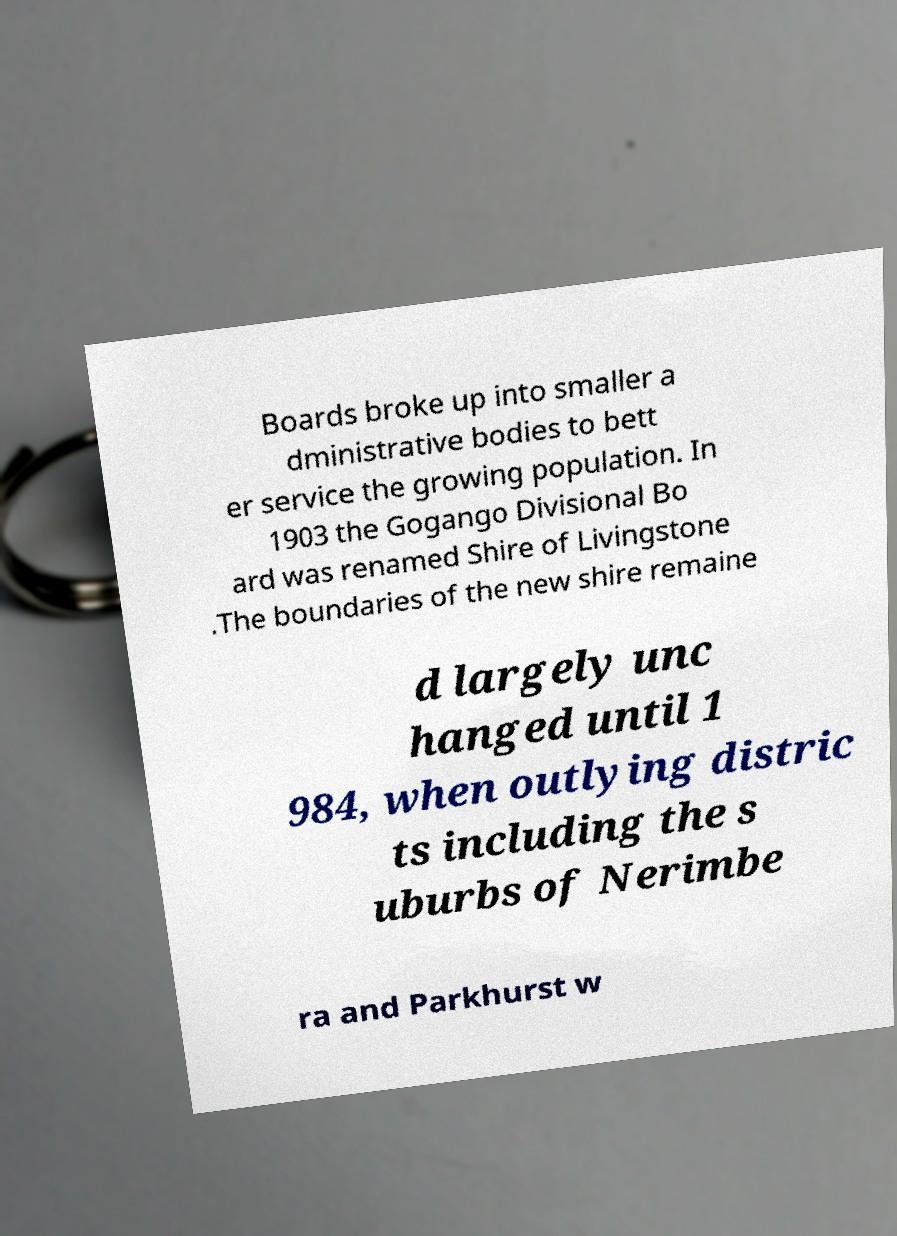Can you read and provide the text displayed in the image?This photo seems to have some interesting text. Can you extract and type it out for me? Boards broke up into smaller a dministrative bodies to bett er service the growing population. In 1903 the Gogango Divisional Bo ard was renamed Shire of Livingstone .The boundaries of the new shire remaine d largely unc hanged until 1 984, when outlying distric ts including the s uburbs of Nerimbe ra and Parkhurst w 